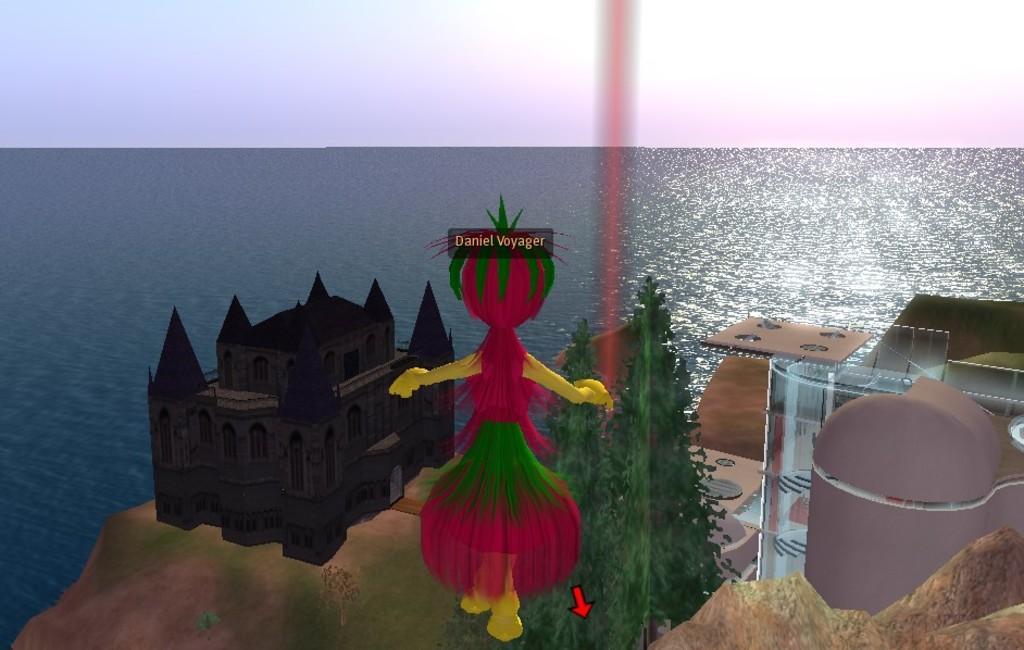Describe this image in one or two sentences. In this image we can see a graphical image of a building ,person ,group of trees, ,water and the sky. 